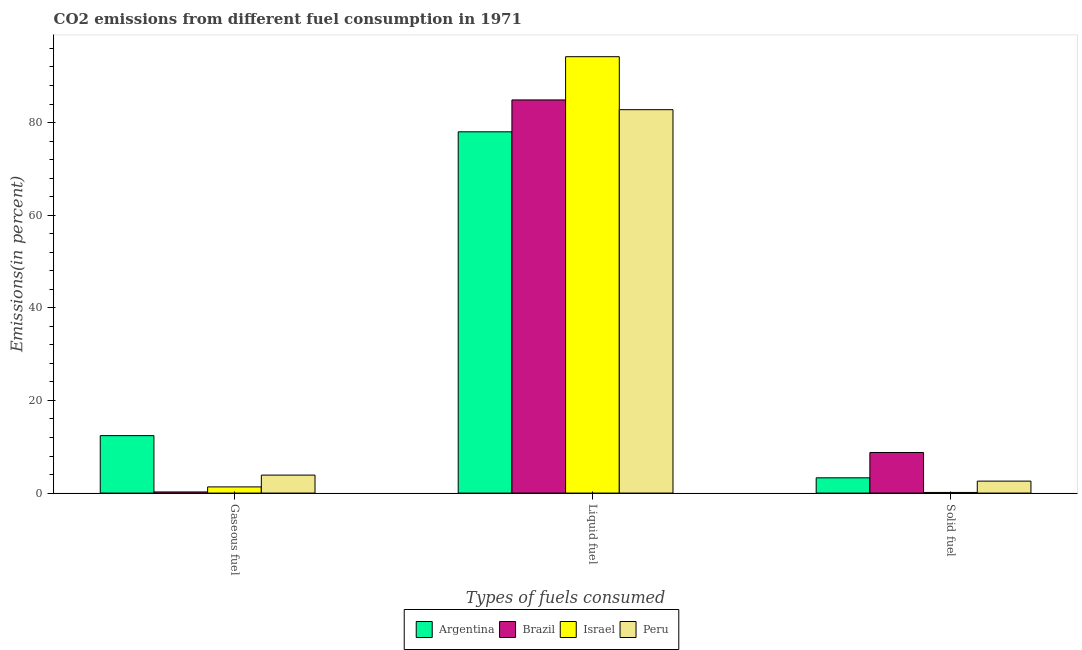How many groups of bars are there?
Make the answer very short. 3. Are the number of bars on each tick of the X-axis equal?
Give a very brief answer. Yes. How many bars are there on the 1st tick from the left?
Keep it short and to the point. 4. How many bars are there on the 1st tick from the right?
Give a very brief answer. 4. What is the label of the 1st group of bars from the left?
Keep it short and to the point. Gaseous fuel. What is the percentage of solid fuel emission in Brazil?
Offer a very short reply. 8.76. Across all countries, what is the maximum percentage of gaseous fuel emission?
Keep it short and to the point. 12.4. Across all countries, what is the minimum percentage of gaseous fuel emission?
Ensure brevity in your answer.  0.24. What is the total percentage of liquid fuel emission in the graph?
Your answer should be very brief. 339.89. What is the difference between the percentage of liquid fuel emission in Peru and that in Argentina?
Provide a short and direct response. 4.78. What is the difference between the percentage of solid fuel emission in Brazil and the percentage of gaseous fuel emission in Argentina?
Provide a short and direct response. -3.64. What is the average percentage of liquid fuel emission per country?
Provide a succinct answer. 84.97. What is the difference between the percentage of gaseous fuel emission and percentage of liquid fuel emission in Peru?
Ensure brevity in your answer.  -78.9. What is the ratio of the percentage of gaseous fuel emission in Israel to that in Peru?
Offer a very short reply. 0.34. What is the difference between the highest and the second highest percentage of liquid fuel emission?
Keep it short and to the point. 9.34. What is the difference between the highest and the lowest percentage of solid fuel emission?
Your answer should be compact. 8.63. In how many countries, is the percentage of gaseous fuel emission greater than the average percentage of gaseous fuel emission taken over all countries?
Make the answer very short. 1. Is the sum of the percentage of gaseous fuel emission in Peru and Israel greater than the maximum percentage of solid fuel emission across all countries?
Give a very brief answer. No. What does the 1st bar from the left in Gaseous fuel represents?
Your answer should be compact. Argentina. Is it the case that in every country, the sum of the percentage of gaseous fuel emission and percentage of liquid fuel emission is greater than the percentage of solid fuel emission?
Ensure brevity in your answer.  Yes. How many bars are there?
Make the answer very short. 12. How many countries are there in the graph?
Give a very brief answer. 4. What is the difference between two consecutive major ticks on the Y-axis?
Ensure brevity in your answer.  20. Are the values on the major ticks of Y-axis written in scientific E-notation?
Ensure brevity in your answer.  No. Does the graph contain grids?
Ensure brevity in your answer.  No. How are the legend labels stacked?
Offer a terse response. Horizontal. What is the title of the graph?
Your answer should be compact. CO2 emissions from different fuel consumption in 1971. Does "Isle of Man" appear as one of the legend labels in the graph?
Provide a short and direct response. No. What is the label or title of the X-axis?
Keep it short and to the point. Types of fuels consumed. What is the label or title of the Y-axis?
Provide a succinct answer. Emissions(in percent). What is the Emissions(in percent) of Argentina in Gaseous fuel?
Your answer should be very brief. 12.4. What is the Emissions(in percent) in Brazil in Gaseous fuel?
Offer a very short reply. 0.24. What is the Emissions(in percent) in Israel in Gaseous fuel?
Your response must be concise. 1.33. What is the Emissions(in percent) in Peru in Gaseous fuel?
Offer a very short reply. 3.88. What is the Emissions(in percent) in Argentina in Liquid fuel?
Provide a succinct answer. 78. What is the Emissions(in percent) in Brazil in Liquid fuel?
Offer a very short reply. 84.89. What is the Emissions(in percent) in Israel in Liquid fuel?
Ensure brevity in your answer.  94.22. What is the Emissions(in percent) of Peru in Liquid fuel?
Give a very brief answer. 82.78. What is the Emissions(in percent) of Argentina in Solid fuel?
Your response must be concise. 3.29. What is the Emissions(in percent) of Brazil in Solid fuel?
Your response must be concise. 8.76. What is the Emissions(in percent) in Israel in Solid fuel?
Keep it short and to the point. 0.14. What is the Emissions(in percent) in Peru in Solid fuel?
Your answer should be very brief. 2.58. Across all Types of fuels consumed, what is the maximum Emissions(in percent) of Argentina?
Your answer should be very brief. 78. Across all Types of fuels consumed, what is the maximum Emissions(in percent) in Brazil?
Offer a very short reply. 84.89. Across all Types of fuels consumed, what is the maximum Emissions(in percent) of Israel?
Your response must be concise. 94.22. Across all Types of fuels consumed, what is the maximum Emissions(in percent) of Peru?
Keep it short and to the point. 82.78. Across all Types of fuels consumed, what is the minimum Emissions(in percent) in Argentina?
Offer a very short reply. 3.29. Across all Types of fuels consumed, what is the minimum Emissions(in percent) in Brazil?
Provide a succinct answer. 0.24. Across all Types of fuels consumed, what is the minimum Emissions(in percent) in Israel?
Make the answer very short. 0.14. Across all Types of fuels consumed, what is the minimum Emissions(in percent) in Peru?
Ensure brevity in your answer.  2.58. What is the total Emissions(in percent) in Argentina in the graph?
Your answer should be very brief. 93.7. What is the total Emissions(in percent) of Brazil in the graph?
Ensure brevity in your answer.  93.89. What is the total Emissions(in percent) of Israel in the graph?
Ensure brevity in your answer.  95.69. What is the total Emissions(in percent) in Peru in the graph?
Ensure brevity in your answer.  89.24. What is the difference between the Emissions(in percent) in Argentina in Gaseous fuel and that in Liquid fuel?
Offer a terse response. -65.6. What is the difference between the Emissions(in percent) in Brazil in Gaseous fuel and that in Liquid fuel?
Your answer should be compact. -84.64. What is the difference between the Emissions(in percent) of Israel in Gaseous fuel and that in Liquid fuel?
Your response must be concise. -92.89. What is the difference between the Emissions(in percent) of Peru in Gaseous fuel and that in Liquid fuel?
Keep it short and to the point. -78.9. What is the difference between the Emissions(in percent) in Argentina in Gaseous fuel and that in Solid fuel?
Offer a very short reply. 9.11. What is the difference between the Emissions(in percent) in Brazil in Gaseous fuel and that in Solid fuel?
Offer a terse response. -8.52. What is the difference between the Emissions(in percent) of Israel in Gaseous fuel and that in Solid fuel?
Provide a short and direct response. 1.2. What is the difference between the Emissions(in percent) in Peru in Gaseous fuel and that in Solid fuel?
Keep it short and to the point. 1.3. What is the difference between the Emissions(in percent) of Argentina in Liquid fuel and that in Solid fuel?
Your answer should be compact. 74.71. What is the difference between the Emissions(in percent) in Brazil in Liquid fuel and that in Solid fuel?
Keep it short and to the point. 76.13. What is the difference between the Emissions(in percent) of Israel in Liquid fuel and that in Solid fuel?
Offer a terse response. 94.09. What is the difference between the Emissions(in percent) in Peru in Liquid fuel and that in Solid fuel?
Offer a very short reply. 80.2. What is the difference between the Emissions(in percent) in Argentina in Gaseous fuel and the Emissions(in percent) in Brazil in Liquid fuel?
Your response must be concise. -72.48. What is the difference between the Emissions(in percent) of Argentina in Gaseous fuel and the Emissions(in percent) of Israel in Liquid fuel?
Your response must be concise. -81.82. What is the difference between the Emissions(in percent) in Argentina in Gaseous fuel and the Emissions(in percent) in Peru in Liquid fuel?
Your answer should be compact. -70.38. What is the difference between the Emissions(in percent) of Brazil in Gaseous fuel and the Emissions(in percent) of Israel in Liquid fuel?
Make the answer very short. -93.98. What is the difference between the Emissions(in percent) in Brazil in Gaseous fuel and the Emissions(in percent) in Peru in Liquid fuel?
Give a very brief answer. -82.54. What is the difference between the Emissions(in percent) of Israel in Gaseous fuel and the Emissions(in percent) of Peru in Liquid fuel?
Your answer should be very brief. -81.45. What is the difference between the Emissions(in percent) of Argentina in Gaseous fuel and the Emissions(in percent) of Brazil in Solid fuel?
Offer a terse response. 3.64. What is the difference between the Emissions(in percent) in Argentina in Gaseous fuel and the Emissions(in percent) in Israel in Solid fuel?
Offer a very short reply. 12.27. What is the difference between the Emissions(in percent) of Argentina in Gaseous fuel and the Emissions(in percent) of Peru in Solid fuel?
Your answer should be very brief. 9.82. What is the difference between the Emissions(in percent) of Brazil in Gaseous fuel and the Emissions(in percent) of Israel in Solid fuel?
Your answer should be compact. 0.11. What is the difference between the Emissions(in percent) of Brazil in Gaseous fuel and the Emissions(in percent) of Peru in Solid fuel?
Give a very brief answer. -2.34. What is the difference between the Emissions(in percent) in Israel in Gaseous fuel and the Emissions(in percent) in Peru in Solid fuel?
Provide a succinct answer. -1.25. What is the difference between the Emissions(in percent) in Argentina in Liquid fuel and the Emissions(in percent) in Brazil in Solid fuel?
Offer a terse response. 69.24. What is the difference between the Emissions(in percent) of Argentina in Liquid fuel and the Emissions(in percent) of Israel in Solid fuel?
Offer a very short reply. 77.87. What is the difference between the Emissions(in percent) of Argentina in Liquid fuel and the Emissions(in percent) of Peru in Solid fuel?
Offer a terse response. 75.42. What is the difference between the Emissions(in percent) in Brazil in Liquid fuel and the Emissions(in percent) in Israel in Solid fuel?
Offer a terse response. 84.75. What is the difference between the Emissions(in percent) in Brazil in Liquid fuel and the Emissions(in percent) in Peru in Solid fuel?
Provide a succinct answer. 82.31. What is the difference between the Emissions(in percent) in Israel in Liquid fuel and the Emissions(in percent) in Peru in Solid fuel?
Keep it short and to the point. 91.64. What is the average Emissions(in percent) in Argentina per Types of fuels consumed?
Provide a short and direct response. 31.23. What is the average Emissions(in percent) of Brazil per Types of fuels consumed?
Offer a terse response. 31.3. What is the average Emissions(in percent) in Israel per Types of fuels consumed?
Provide a succinct answer. 31.9. What is the average Emissions(in percent) of Peru per Types of fuels consumed?
Ensure brevity in your answer.  29.75. What is the difference between the Emissions(in percent) of Argentina and Emissions(in percent) of Brazil in Gaseous fuel?
Offer a very short reply. 12.16. What is the difference between the Emissions(in percent) of Argentina and Emissions(in percent) of Israel in Gaseous fuel?
Give a very brief answer. 11.07. What is the difference between the Emissions(in percent) in Argentina and Emissions(in percent) in Peru in Gaseous fuel?
Provide a short and direct response. 8.52. What is the difference between the Emissions(in percent) of Brazil and Emissions(in percent) of Israel in Gaseous fuel?
Offer a very short reply. -1.09. What is the difference between the Emissions(in percent) of Brazil and Emissions(in percent) of Peru in Gaseous fuel?
Offer a very short reply. -3.64. What is the difference between the Emissions(in percent) of Israel and Emissions(in percent) of Peru in Gaseous fuel?
Offer a very short reply. -2.55. What is the difference between the Emissions(in percent) of Argentina and Emissions(in percent) of Brazil in Liquid fuel?
Provide a succinct answer. -6.88. What is the difference between the Emissions(in percent) in Argentina and Emissions(in percent) in Israel in Liquid fuel?
Keep it short and to the point. -16.22. What is the difference between the Emissions(in percent) in Argentina and Emissions(in percent) in Peru in Liquid fuel?
Give a very brief answer. -4.78. What is the difference between the Emissions(in percent) in Brazil and Emissions(in percent) in Israel in Liquid fuel?
Offer a very short reply. -9.34. What is the difference between the Emissions(in percent) of Brazil and Emissions(in percent) of Peru in Liquid fuel?
Make the answer very short. 2.11. What is the difference between the Emissions(in percent) of Israel and Emissions(in percent) of Peru in Liquid fuel?
Make the answer very short. 11.44. What is the difference between the Emissions(in percent) in Argentina and Emissions(in percent) in Brazil in Solid fuel?
Your response must be concise. -5.47. What is the difference between the Emissions(in percent) in Argentina and Emissions(in percent) in Israel in Solid fuel?
Provide a succinct answer. 3.16. What is the difference between the Emissions(in percent) of Argentina and Emissions(in percent) of Peru in Solid fuel?
Keep it short and to the point. 0.71. What is the difference between the Emissions(in percent) of Brazil and Emissions(in percent) of Israel in Solid fuel?
Ensure brevity in your answer.  8.63. What is the difference between the Emissions(in percent) in Brazil and Emissions(in percent) in Peru in Solid fuel?
Keep it short and to the point. 6.18. What is the difference between the Emissions(in percent) in Israel and Emissions(in percent) in Peru in Solid fuel?
Keep it short and to the point. -2.45. What is the ratio of the Emissions(in percent) in Argentina in Gaseous fuel to that in Liquid fuel?
Provide a succinct answer. 0.16. What is the ratio of the Emissions(in percent) in Brazil in Gaseous fuel to that in Liquid fuel?
Ensure brevity in your answer.  0. What is the ratio of the Emissions(in percent) in Israel in Gaseous fuel to that in Liquid fuel?
Make the answer very short. 0.01. What is the ratio of the Emissions(in percent) of Peru in Gaseous fuel to that in Liquid fuel?
Ensure brevity in your answer.  0.05. What is the ratio of the Emissions(in percent) of Argentina in Gaseous fuel to that in Solid fuel?
Your response must be concise. 3.76. What is the ratio of the Emissions(in percent) in Brazil in Gaseous fuel to that in Solid fuel?
Provide a succinct answer. 0.03. What is the ratio of the Emissions(in percent) in Israel in Gaseous fuel to that in Solid fuel?
Ensure brevity in your answer.  9.83. What is the ratio of the Emissions(in percent) in Peru in Gaseous fuel to that in Solid fuel?
Your answer should be compact. 1.5. What is the ratio of the Emissions(in percent) in Argentina in Liquid fuel to that in Solid fuel?
Provide a succinct answer. 23.68. What is the ratio of the Emissions(in percent) of Brazil in Liquid fuel to that in Solid fuel?
Offer a very short reply. 9.69. What is the ratio of the Emissions(in percent) of Israel in Liquid fuel to that in Solid fuel?
Provide a succinct answer. 695.83. What is the ratio of the Emissions(in percent) in Peru in Liquid fuel to that in Solid fuel?
Keep it short and to the point. 32.08. What is the difference between the highest and the second highest Emissions(in percent) of Argentina?
Offer a terse response. 65.6. What is the difference between the highest and the second highest Emissions(in percent) of Brazil?
Keep it short and to the point. 76.13. What is the difference between the highest and the second highest Emissions(in percent) of Israel?
Give a very brief answer. 92.89. What is the difference between the highest and the second highest Emissions(in percent) in Peru?
Your answer should be very brief. 78.9. What is the difference between the highest and the lowest Emissions(in percent) of Argentina?
Provide a succinct answer. 74.71. What is the difference between the highest and the lowest Emissions(in percent) in Brazil?
Provide a short and direct response. 84.64. What is the difference between the highest and the lowest Emissions(in percent) of Israel?
Make the answer very short. 94.09. What is the difference between the highest and the lowest Emissions(in percent) of Peru?
Offer a terse response. 80.2. 